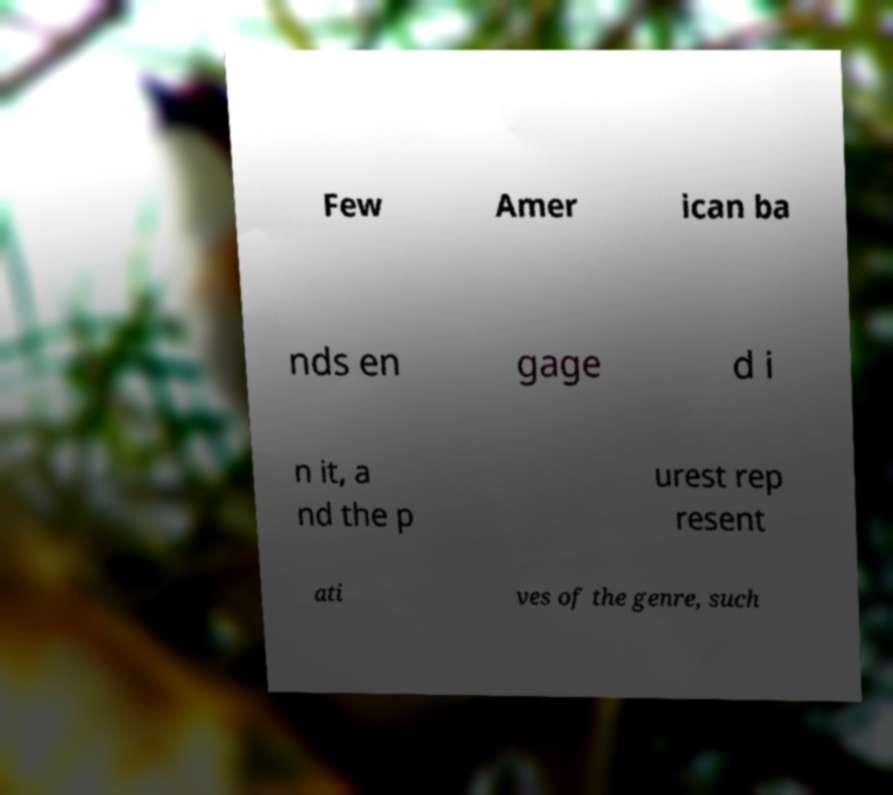Could you assist in decoding the text presented in this image and type it out clearly? Few Amer ican ba nds en gage d i n it, a nd the p urest rep resent ati ves of the genre, such 